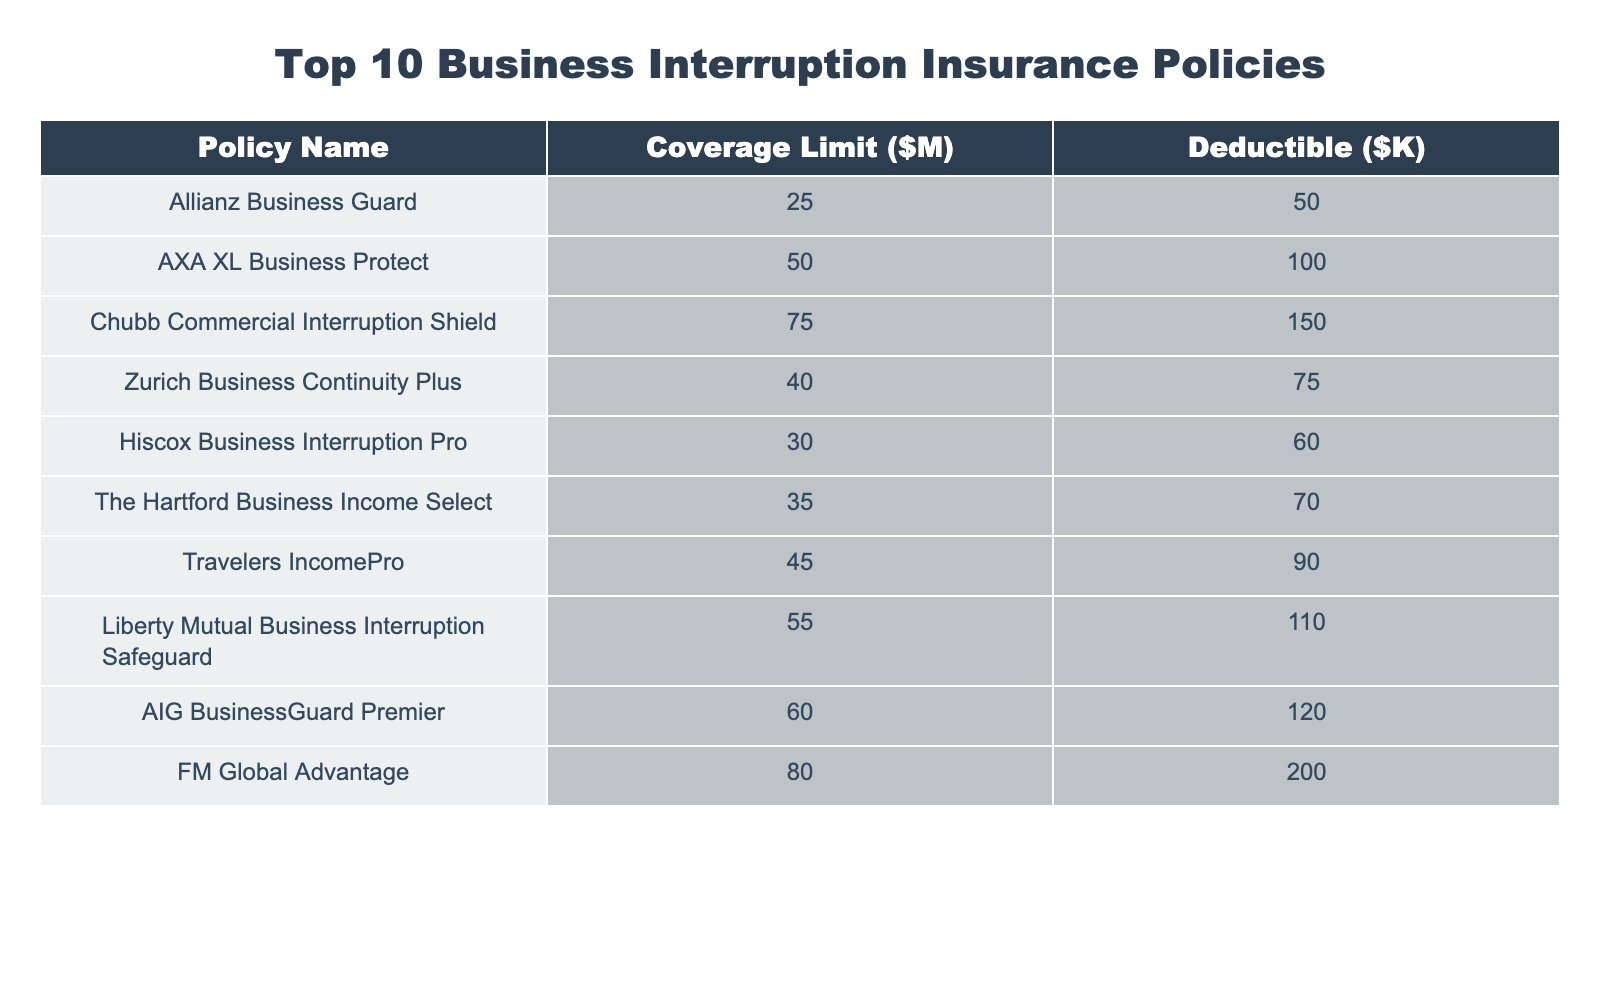What is the maximum coverage limit among the listed policies? The maximum coverage limit can be found by scanning the "Coverage Limit" column. The highest value is 80 million, associated with the FM Global Advantage policy.
Answer: 80 million Which policy has the lowest deductible? To determine the lowest deductible, we look at the "Deductible" column and identify the smallest value, which is 50, tied to the Allianz Business Guard policy.
Answer: 50 What is the average coverage limit of all the policies? We add all the coverage limits: (25 + 50 + 75 + 40 + 30 + 35 + 45 + 55 + 60 + 80) = 450 million. Dividing by the total number of policies (10) gives us 450 / 10 = 45 million.
Answer: 45 million Is the deductible for the Zurich Business Continuity Plus policy higher than 80K? The deductible for the Zurich policy is 75K, which is less than 80K. Therefore, the answer is no.
Answer: No Which policies have a coverage limit greater than 50 million? From the Coverage Limit column, the policies meeting this criterion are Chubb Commercial Interruption Shield (75M), Liberty Mutual Business Interruption Safeguard (55M), and FM Global Advantage (80M).
Answer: 3 policies What is the difference in coverage limit between the policy with the highest coverage and the one with the lowest? The policy with the highest coverage is FM Global Advantage at 80M, and the lowest is Allianz Business Guard at 25M. The difference is 80 - 25 = 55 million.
Answer: 55 million Are there any policies with deductibles lower than 60K? Looking into the Deductible column, both Allianz Business Guard and Hiscox Business Interruption Pro have deductibles lower than 60K (50K and 60K respectively). Thus, the answer is yes.
Answer: Yes Which policy provides the greatest gap between coverage limit and deductible? We calculate the gap for each policy by subtracting the deductible from the coverage limit: For example, FM Global Advantage gap = 80M - 200K = 79.8M. After calculating for all, the highest gap is found with FM Global Advantage at 79.8M.
Answer: FM Global Advantage What is the total amount of deductibles across all policies? We add all the deductibles found in the Deductible column: (50 + 100 + 150 + 75 + 60 + 70 + 90 + 110 + 120 + 200) = 1025K.
Answer: 1025K Which policy has the second lowest deductible? After reviewing the Deductible column, the second lowest deductible is 60K, which belongs to Hiscox Business Interruption Pro.
Answer: Hiscox Business Interruption Pro 